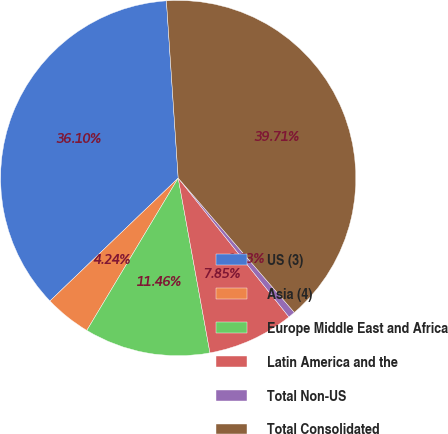Convert chart to OTSL. <chart><loc_0><loc_0><loc_500><loc_500><pie_chart><fcel>US (3)<fcel>Asia (4)<fcel>Europe Middle East and Africa<fcel>Latin America and the<fcel>Total Non-US<fcel>Total Consolidated<nl><fcel>36.1%<fcel>4.24%<fcel>11.46%<fcel>7.85%<fcel>0.63%<fcel>39.71%<nl></chart> 